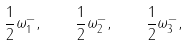<formula> <loc_0><loc_0><loc_500><loc_500>\frac { 1 } { 2 } \omega ^ { - } _ { 1 } , \quad \frac { 1 } { 2 } \omega ^ { - } _ { 2 } , \quad \frac { 1 } { 2 } \omega ^ { - } _ { 3 } ,</formula> 